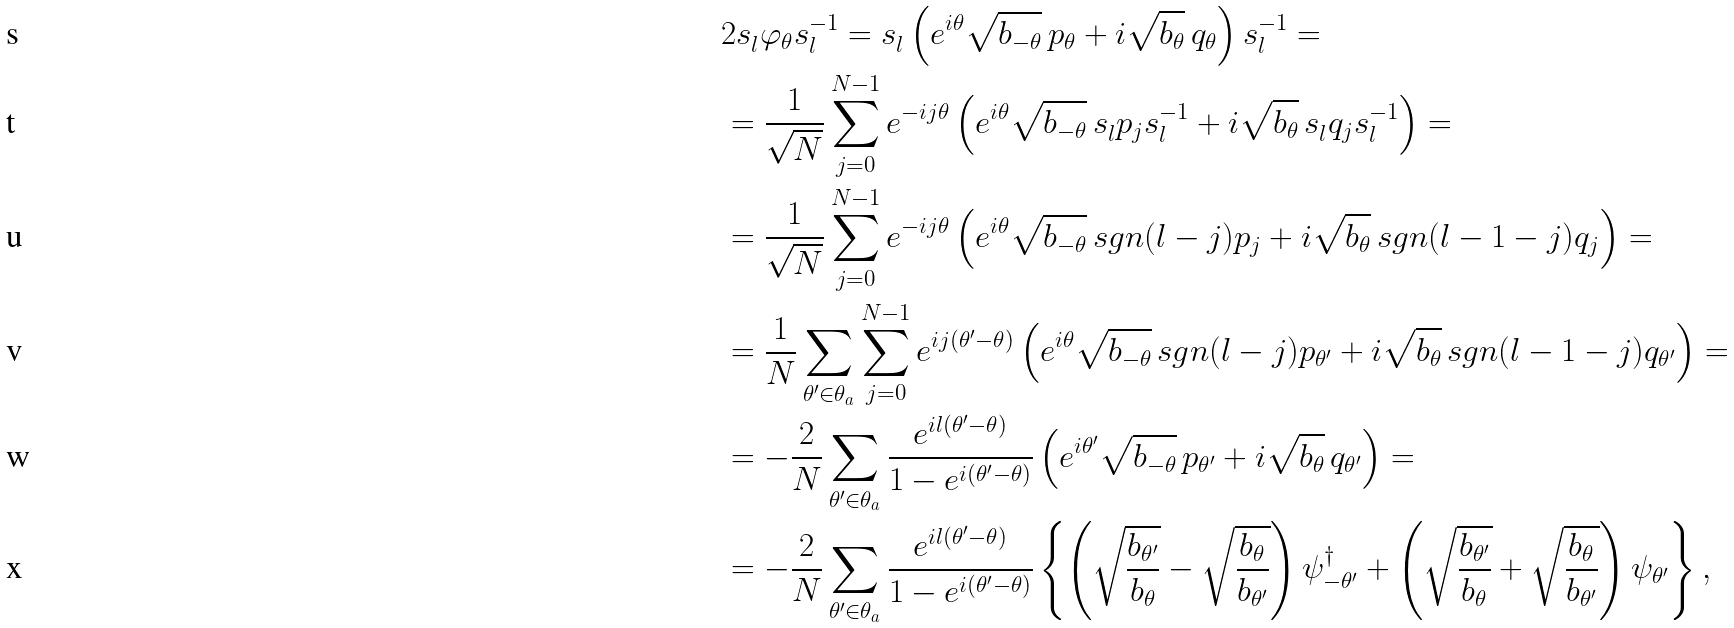Convert formula to latex. <formula><loc_0><loc_0><loc_500><loc_500>& 2 s _ { l } ^ { \, } \varphi _ { \theta } s _ { l } ^ { - 1 } = s _ { l } ^ { \, } \left ( e ^ { i \theta } \sqrt { b _ { - \theta } } \, p _ { \theta } + i \sqrt { b _ { \theta } } \, q _ { \theta } \right ) s _ { l } ^ { - 1 } = \\ & = \frac { 1 } { \sqrt { N } } \sum _ { j = 0 } ^ { N - 1 } e ^ { - i j \theta } \left ( e ^ { i \theta } \sqrt { b _ { - \theta } } \, s ^ { \, } _ { l } p _ { j } s ^ { - 1 } _ { l } + i \sqrt { b _ { \theta } } \, s ^ { \, } _ { l } q _ { j } s ^ { - 1 } _ { l } \right ) = \\ & = \frac { 1 } { \sqrt { N } } \sum _ { j = 0 } ^ { N - 1 } e ^ { - i j \theta } \left ( e ^ { i \theta } \sqrt { b _ { - \theta } } \, s g n ( l - j ) p _ { j } + i \sqrt { b _ { \theta } } \, s g n ( l - 1 - j ) q _ { j } \right ) = \\ & = \frac { 1 } { N } \sum _ { \theta ^ { \prime } \in \theta _ { a } } \sum _ { j = 0 } ^ { N - 1 } e ^ { i j ( \theta ^ { \prime } - \theta ) } \left ( e ^ { i \theta } \sqrt { b _ { - \theta } } \, s g n ( l - j ) p _ { \theta ^ { \prime } } + i \sqrt { b _ { \theta } } \, s g n ( l - 1 - j ) q _ { \theta ^ { \prime } } \right ) = \\ & = - \frac { 2 } { N } \sum _ { \theta ^ { \prime } \in \theta _ { a } } \frac { e ^ { i l ( \theta ^ { \prime } - \theta ) } } { 1 - e ^ { i ( \theta ^ { \prime } - \theta ) } } \left ( e ^ { i \theta ^ { \prime } } \sqrt { b _ { - \theta } } \, p _ { \theta ^ { \prime } } + i \sqrt { b _ { \theta } } \, q _ { \theta ^ { \prime } } \right ) = \\ & = - \frac { 2 } { N } \sum _ { \theta ^ { \prime } \in \theta _ { a } } \frac { e ^ { i l ( \theta ^ { \prime } - \theta ) } } { 1 - e ^ { i ( \theta ^ { \prime } - \theta ) } } \left \{ \left ( \sqrt { \frac { b _ { \theta ^ { \prime } } } { b _ { \theta } } } - \sqrt { \frac { b _ { \theta } } { b _ { \theta ^ { \prime } } } } \right ) \psi ^ { \dag } _ { - \theta ^ { \prime } } + \left ( \sqrt { \frac { b _ { \theta ^ { \prime } } } { b _ { \theta } } } + \sqrt { \frac { b _ { \theta } } { b _ { \theta ^ { \prime } } } } \right ) \psi _ { \theta ^ { \prime } } \right \} ,</formula> 